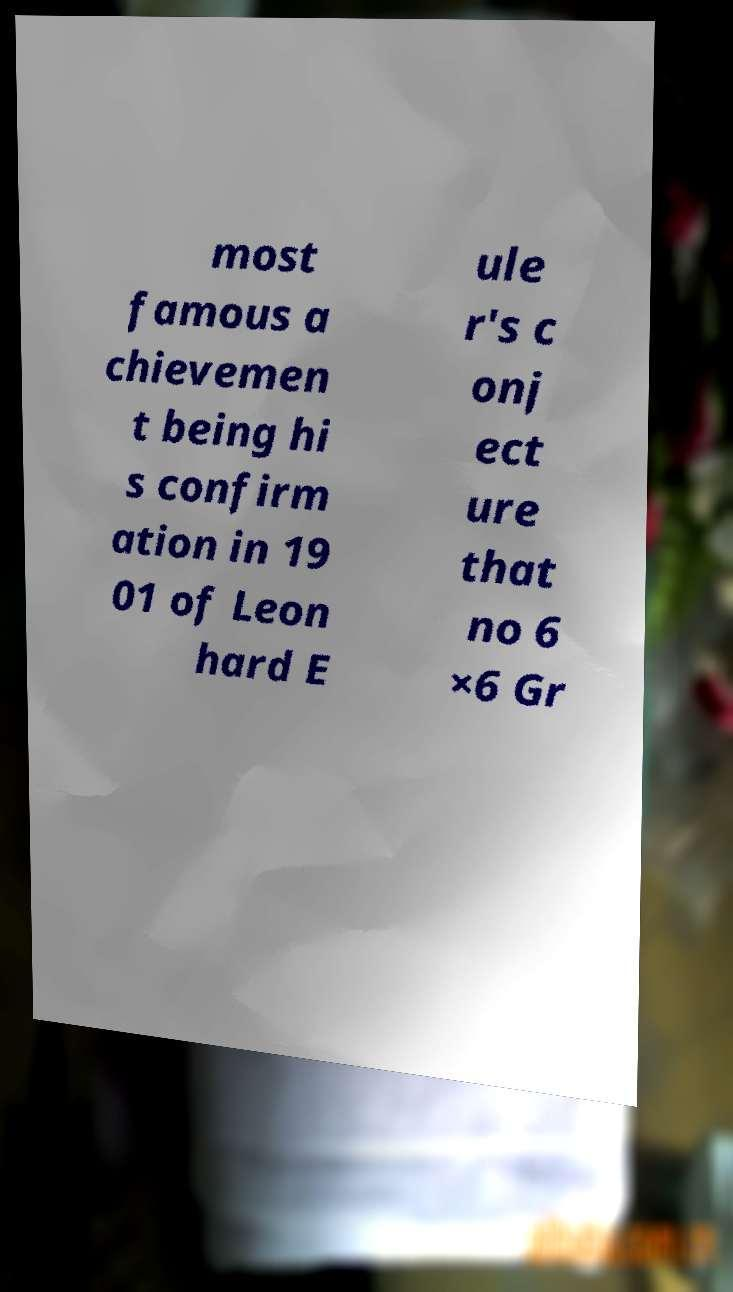Can you read and provide the text displayed in the image?This photo seems to have some interesting text. Can you extract and type it out for me? most famous a chievemen t being hi s confirm ation in 19 01 of Leon hard E ule r's c onj ect ure that no 6 ×6 Gr 